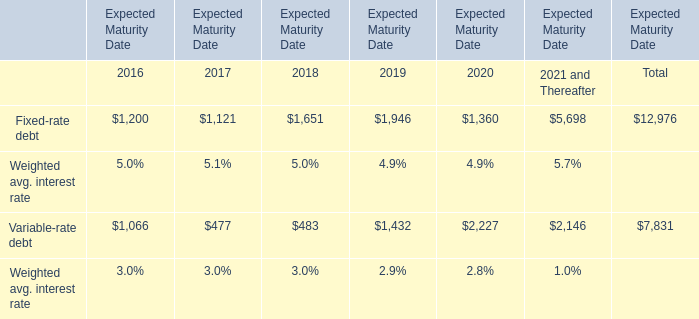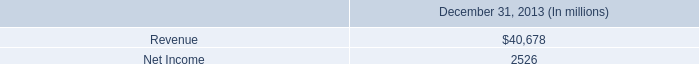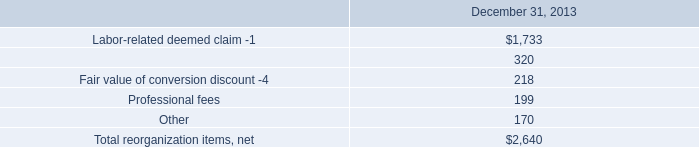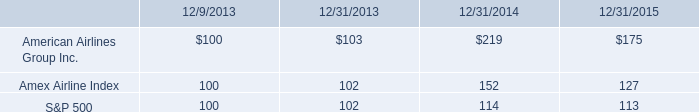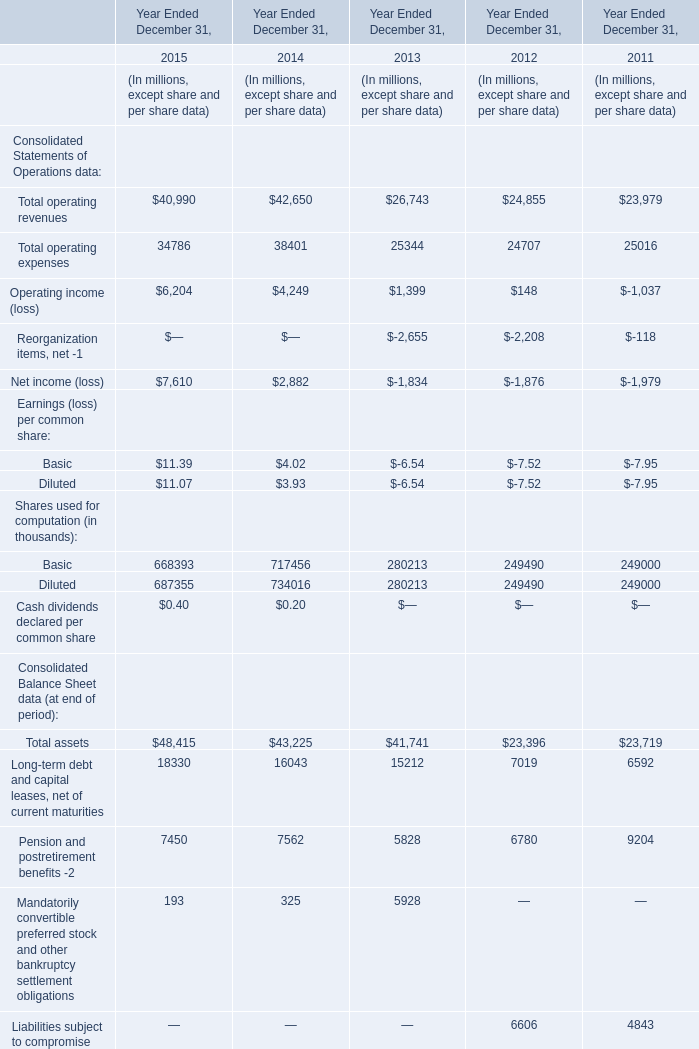What is the sum of Net income (loss) in 2014 and Variable-rate debt in 2020? (in million) 
Computations: (2882 + 2227)
Answer: 5109.0. 